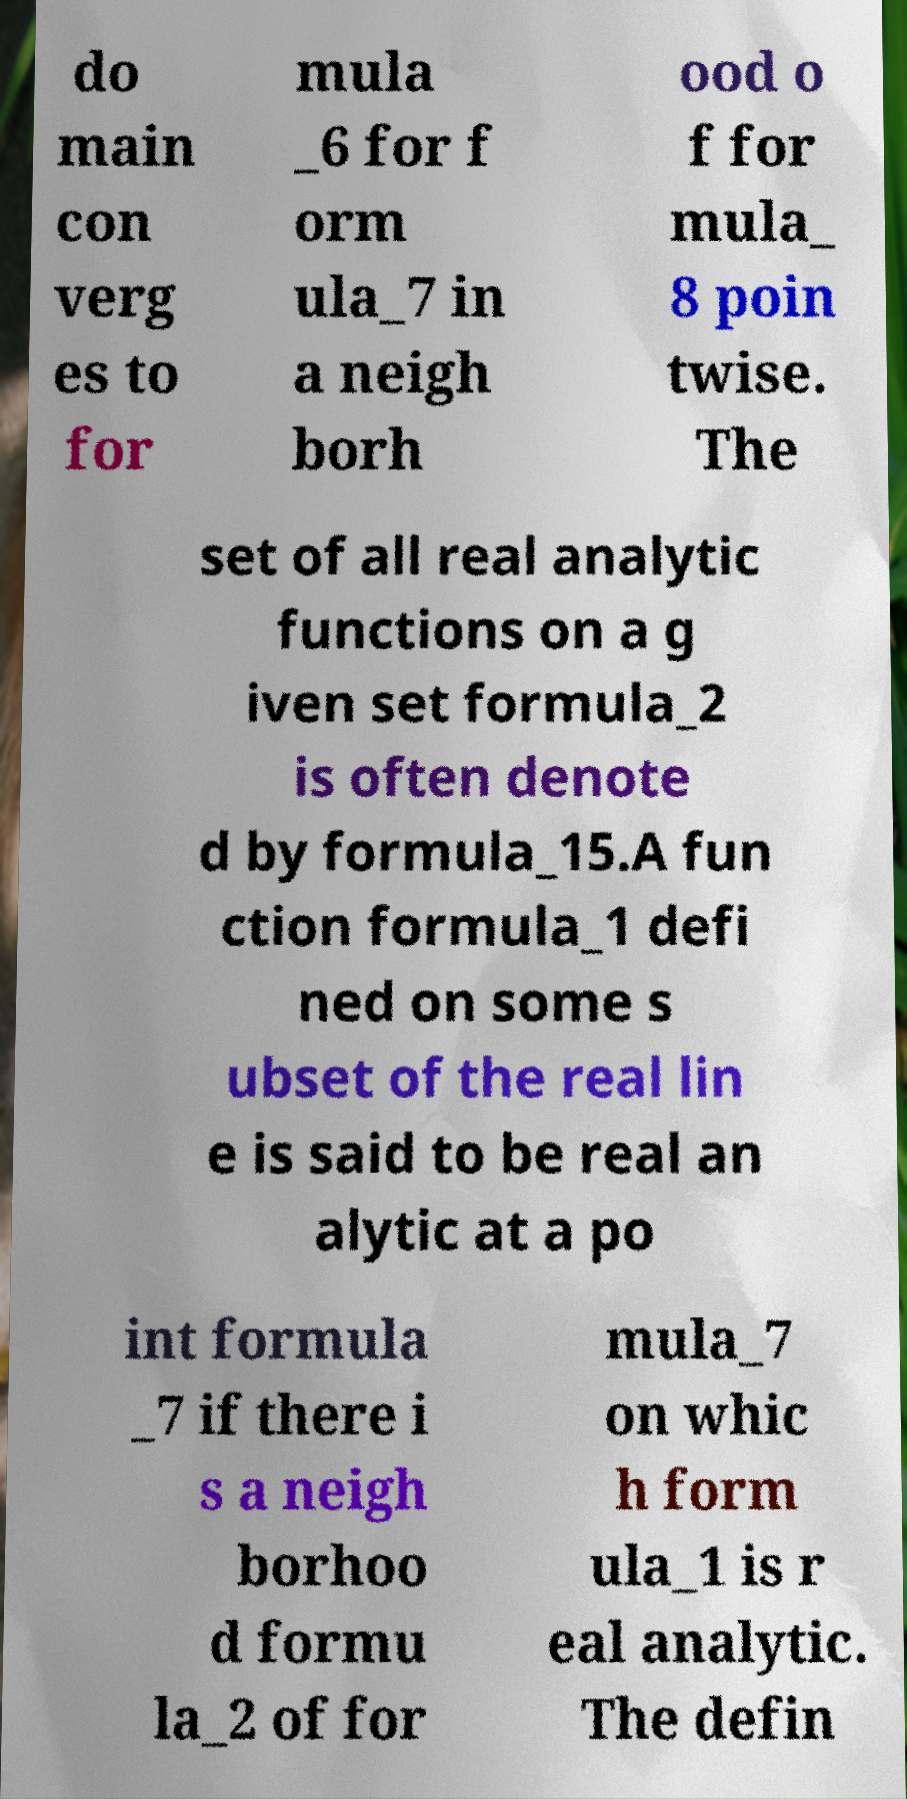Please read and relay the text visible in this image. What does it say? do main con verg es to for mula _6 for f orm ula_7 in a neigh borh ood o f for mula_ 8 poin twise. The set of all real analytic functions on a g iven set formula_2 is often denote d by formula_15.A fun ction formula_1 defi ned on some s ubset of the real lin e is said to be real an alytic at a po int formula _7 if there i s a neigh borhoo d formu la_2 of for mula_7 on whic h form ula_1 is r eal analytic. The defin 